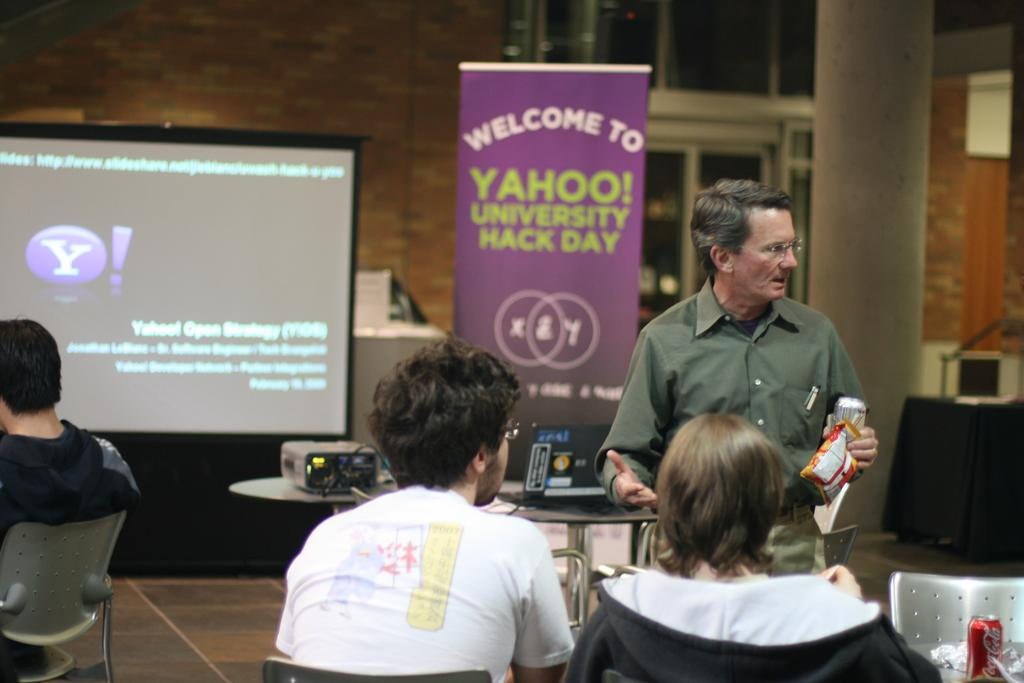How many people are in the image? There are multiple people in the image. What are the people in the image doing? The people are sitting, except for one man who is standing. What can be seen in the background of the image? There is a projector and a projector screen in the background. What type of cheese is being served to the people in the image? There is no cheese present in the image. What is the sister of the man standing doing in the image? There is no mention of a sister in the image, and the man standing is the only person standing. 